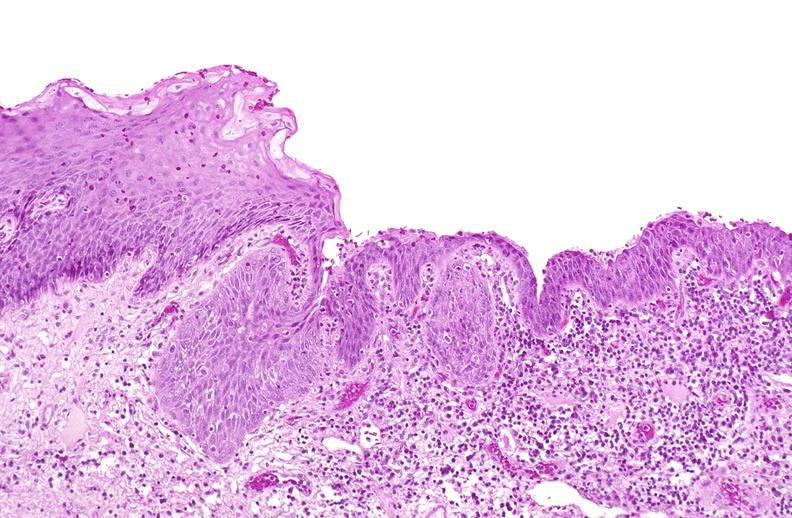what does this image show?
Answer the question using a single word or phrase. Squamous metaplasia 